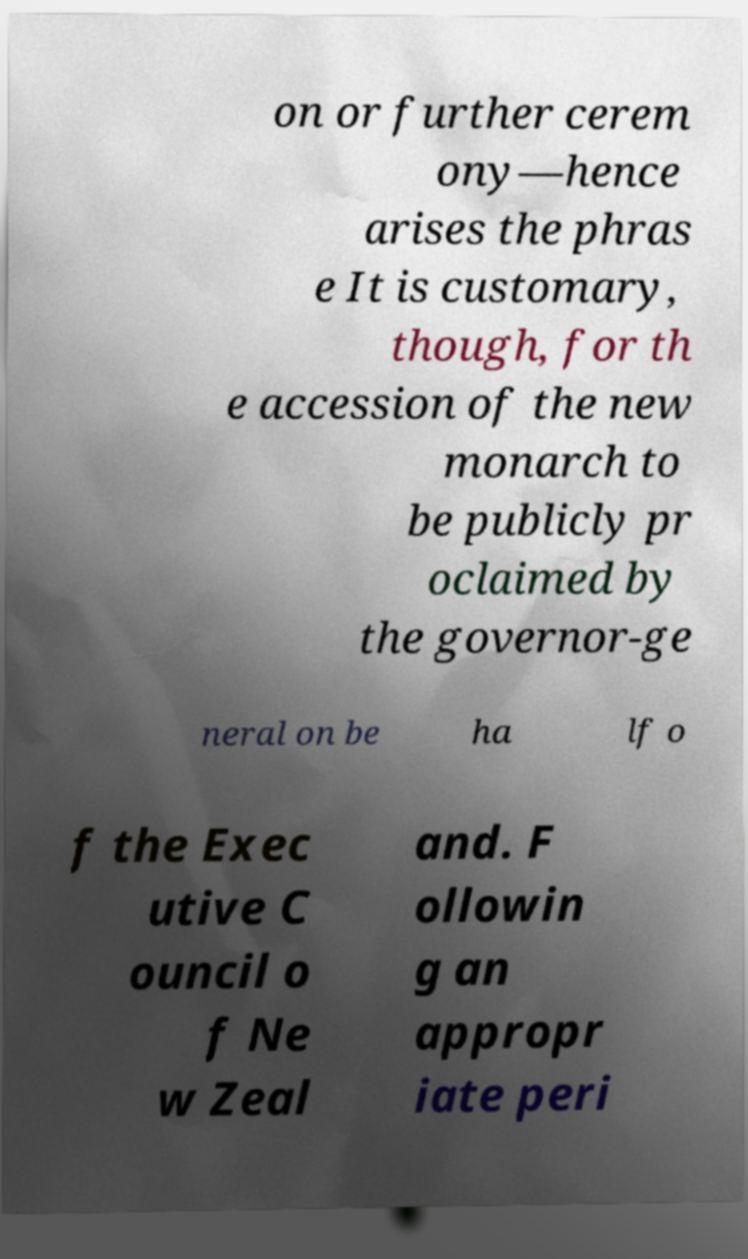Can you accurately transcribe the text from the provided image for me? on or further cerem ony—hence arises the phras e It is customary, though, for th e accession of the new monarch to be publicly pr oclaimed by the governor-ge neral on be ha lf o f the Exec utive C ouncil o f Ne w Zeal and. F ollowin g an appropr iate peri 